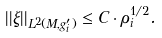<formula> <loc_0><loc_0><loc_500><loc_500>| | \xi | | _ { L ^ { 2 } ( M , g _ { i } ^ { \prime } ) } \leq C \cdot \rho _ { i } ^ { 1 / 2 } .</formula> 